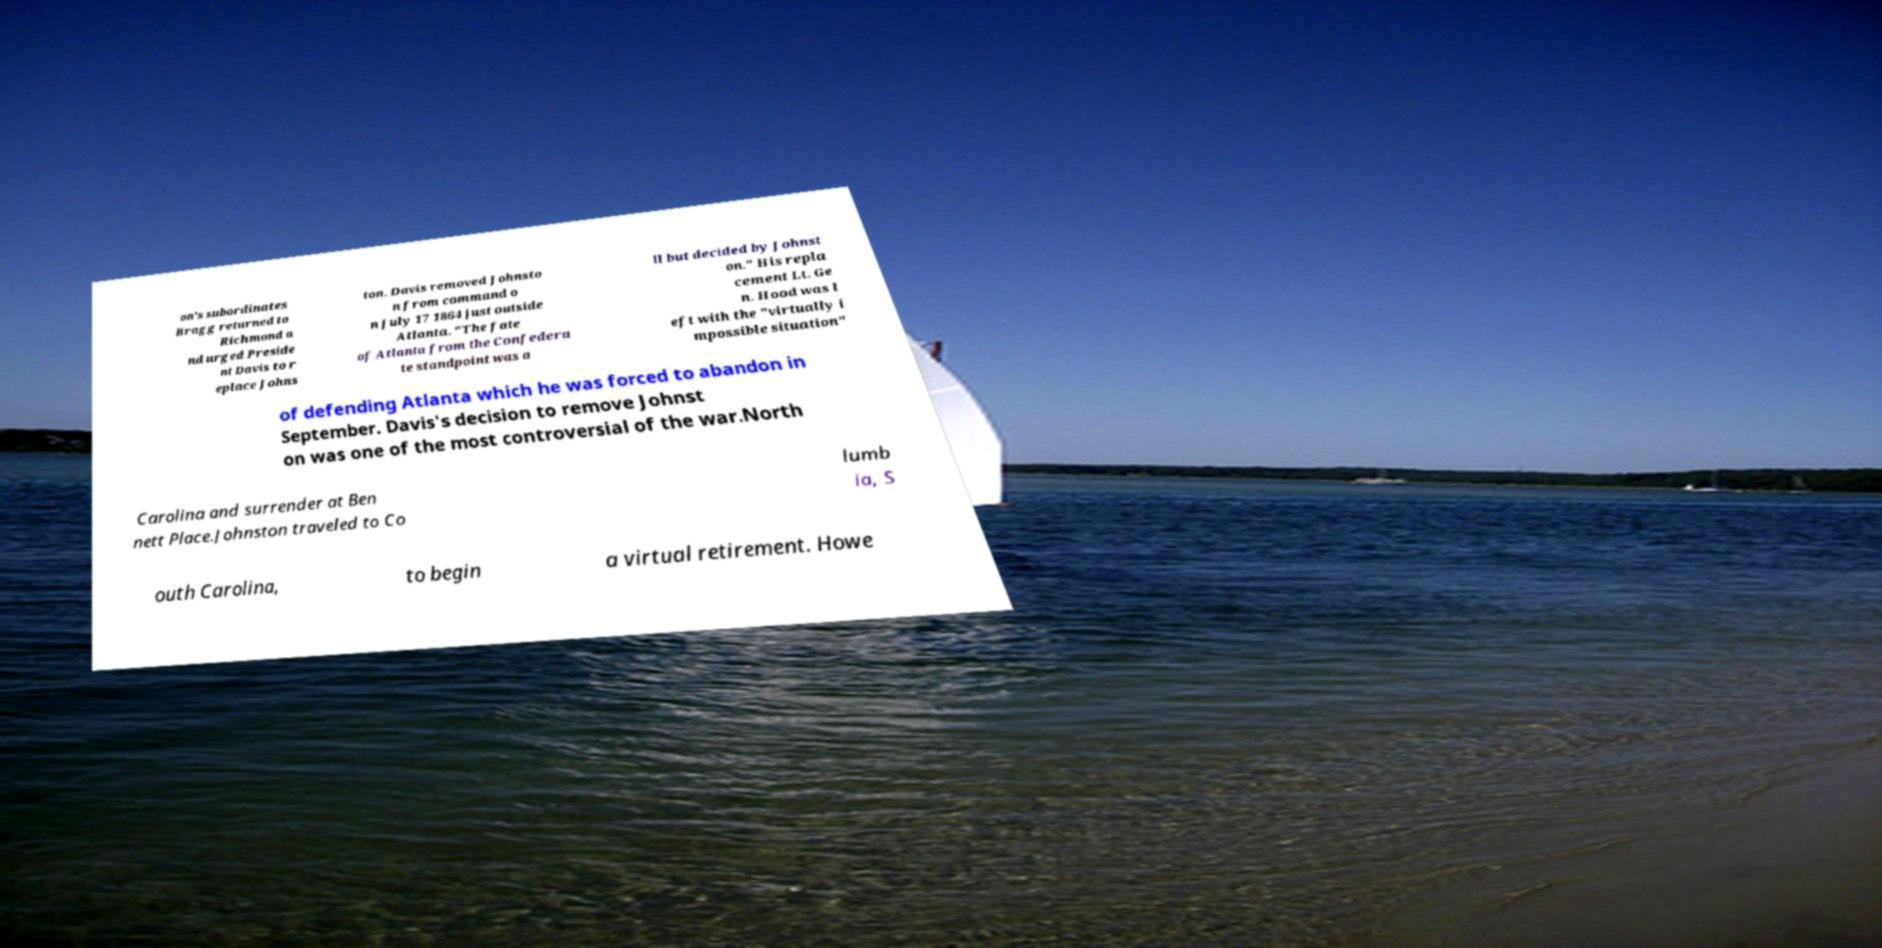Can you accurately transcribe the text from the provided image for me? on's subordinates Bragg returned to Richmond a nd urged Preside nt Davis to r eplace Johns ton. Davis removed Johnsto n from command o n July 17 1864 just outside Atlanta. "The fate of Atlanta from the Confedera te standpoint was a ll but decided by Johnst on." His repla cement Lt. Ge n. Hood was l eft with the "virtually i mpossible situation" of defending Atlanta which he was forced to abandon in September. Davis's decision to remove Johnst on was one of the most controversial of the war.North Carolina and surrender at Ben nett Place.Johnston traveled to Co lumb ia, S outh Carolina, to begin a virtual retirement. Howe 